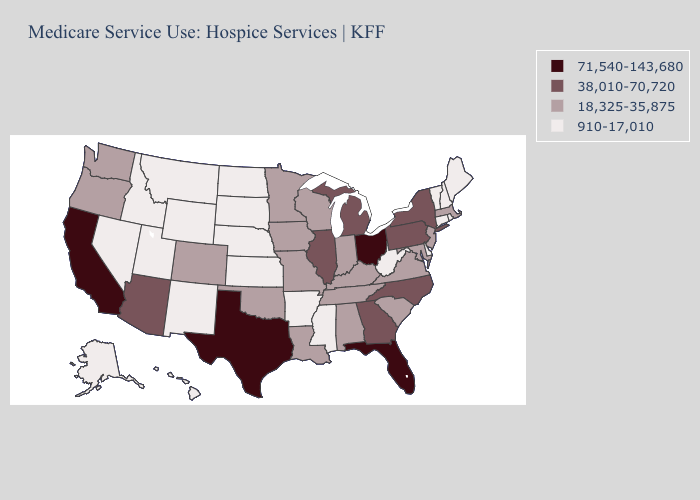What is the value of Tennessee?
Write a very short answer. 18,325-35,875. Name the states that have a value in the range 38,010-70,720?
Give a very brief answer. Arizona, Georgia, Illinois, Michigan, New York, North Carolina, Pennsylvania. Name the states that have a value in the range 71,540-143,680?
Concise answer only. California, Florida, Ohio, Texas. What is the value of Minnesota?
Be succinct. 18,325-35,875. Name the states that have a value in the range 38,010-70,720?
Write a very short answer. Arizona, Georgia, Illinois, Michigan, New York, North Carolina, Pennsylvania. What is the highest value in states that border Pennsylvania?
Give a very brief answer. 71,540-143,680. Among the states that border Minnesota , which have the lowest value?
Write a very short answer. North Dakota, South Dakota. What is the highest value in the Northeast ?
Write a very short answer. 38,010-70,720. What is the value of North Carolina?
Concise answer only. 38,010-70,720. Which states have the lowest value in the USA?
Write a very short answer. Alaska, Arkansas, Connecticut, Delaware, Hawaii, Idaho, Kansas, Maine, Mississippi, Montana, Nebraska, Nevada, New Hampshire, New Mexico, North Dakota, Rhode Island, South Dakota, Utah, Vermont, West Virginia, Wyoming. What is the highest value in states that border Arizona?
Be succinct. 71,540-143,680. What is the value of Texas?
Concise answer only. 71,540-143,680. What is the value of Nebraska?
Keep it brief. 910-17,010. How many symbols are there in the legend?
Answer briefly. 4. What is the value of New Mexico?
Concise answer only. 910-17,010. 